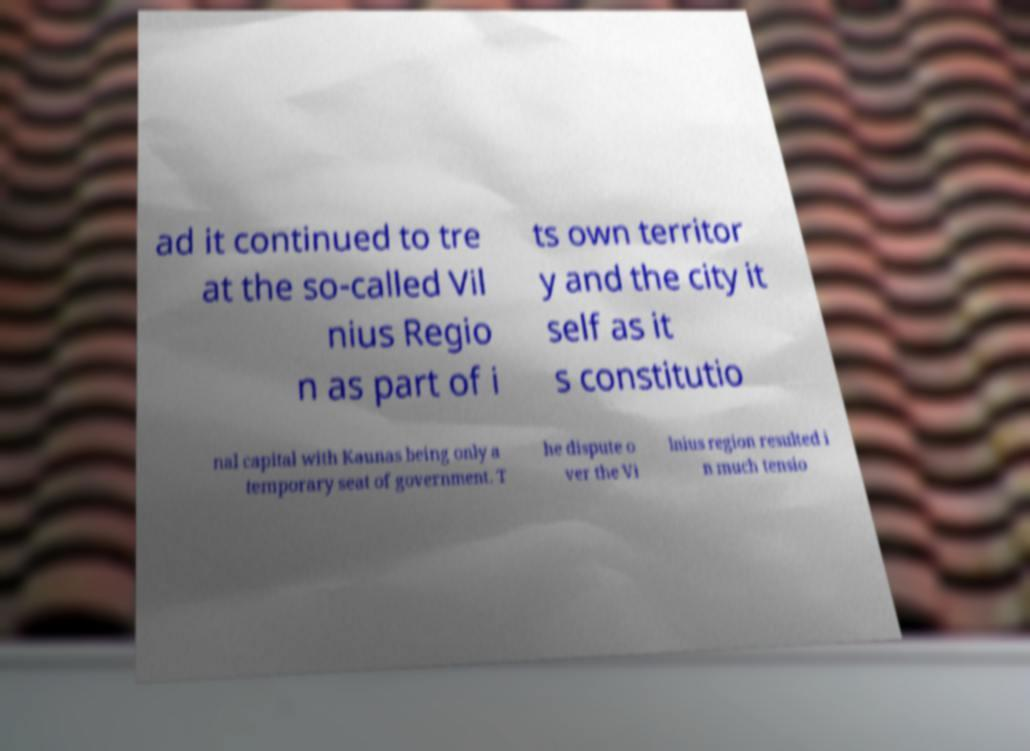Could you assist in decoding the text presented in this image and type it out clearly? ad it continued to tre at the so-called Vil nius Regio n as part of i ts own territor y and the city it self as it s constitutio nal capital with Kaunas being only a temporary seat of government. T he dispute o ver the Vi lnius region resulted i n much tensio 